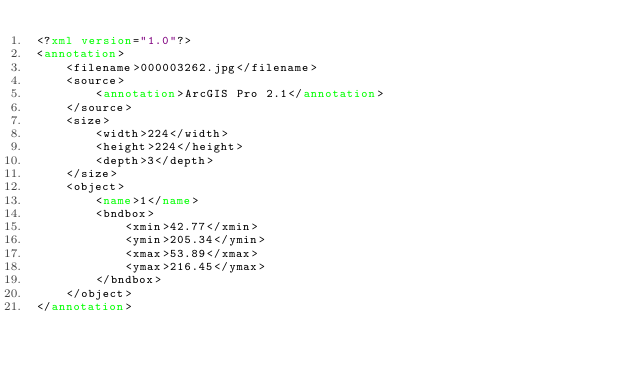<code> <loc_0><loc_0><loc_500><loc_500><_XML_><?xml version="1.0"?>
<annotation>
    <filename>000003262.jpg</filename>
    <source>
        <annotation>ArcGIS Pro 2.1</annotation>
    </source>
    <size>
        <width>224</width>
        <height>224</height>
        <depth>3</depth>
    </size>
    <object>
        <name>1</name>
        <bndbox>
            <xmin>42.77</xmin>
            <ymin>205.34</ymin>
            <xmax>53.89</xmax>
            <ymax>216.45</ymax>
        </bndbox>
    </object>
</annotation>
</code> 